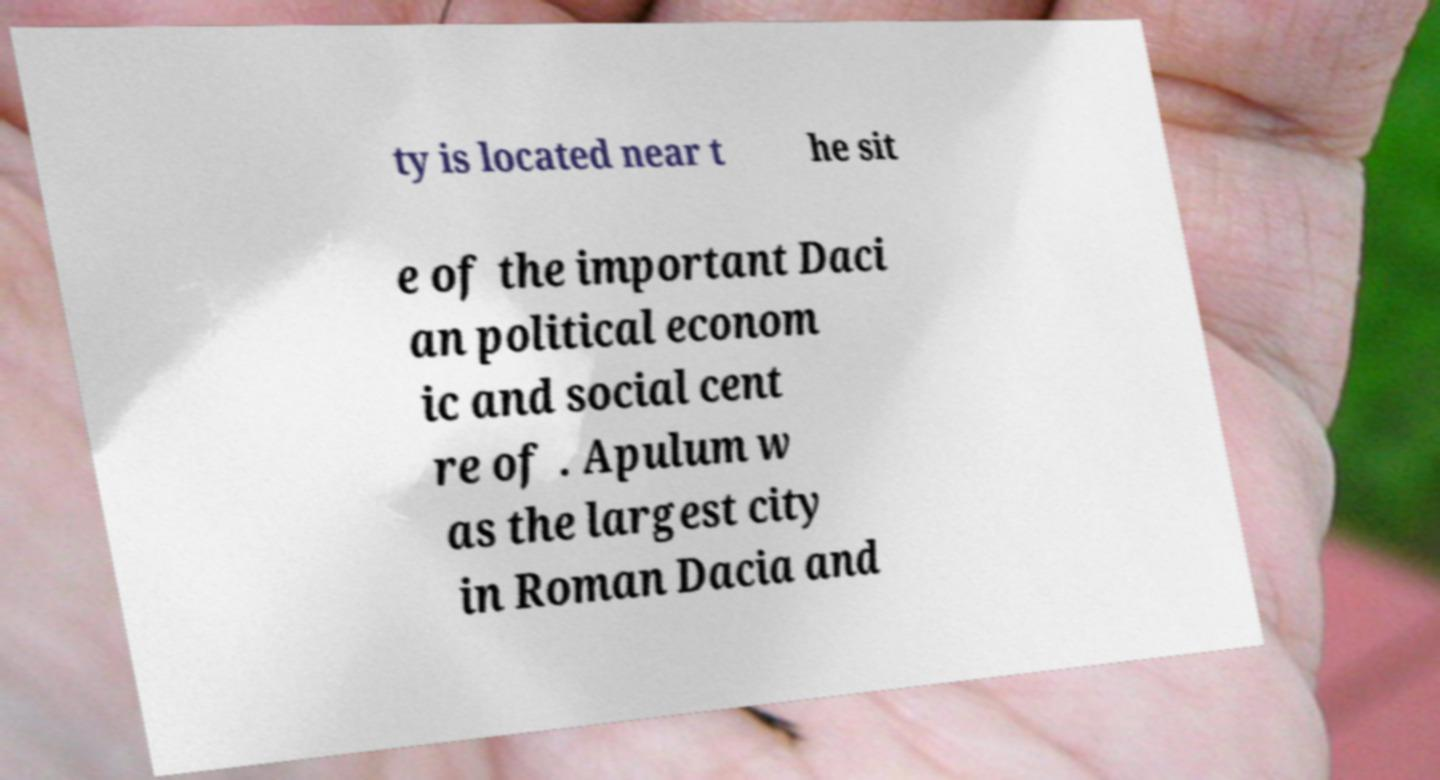Could you assist in decoding the text presented in this image and type it out clearly? ty is located near t he sit e of the important Daci an political econom ic and social cent re of . Apulum w as the largest city in Roman Dacia and 